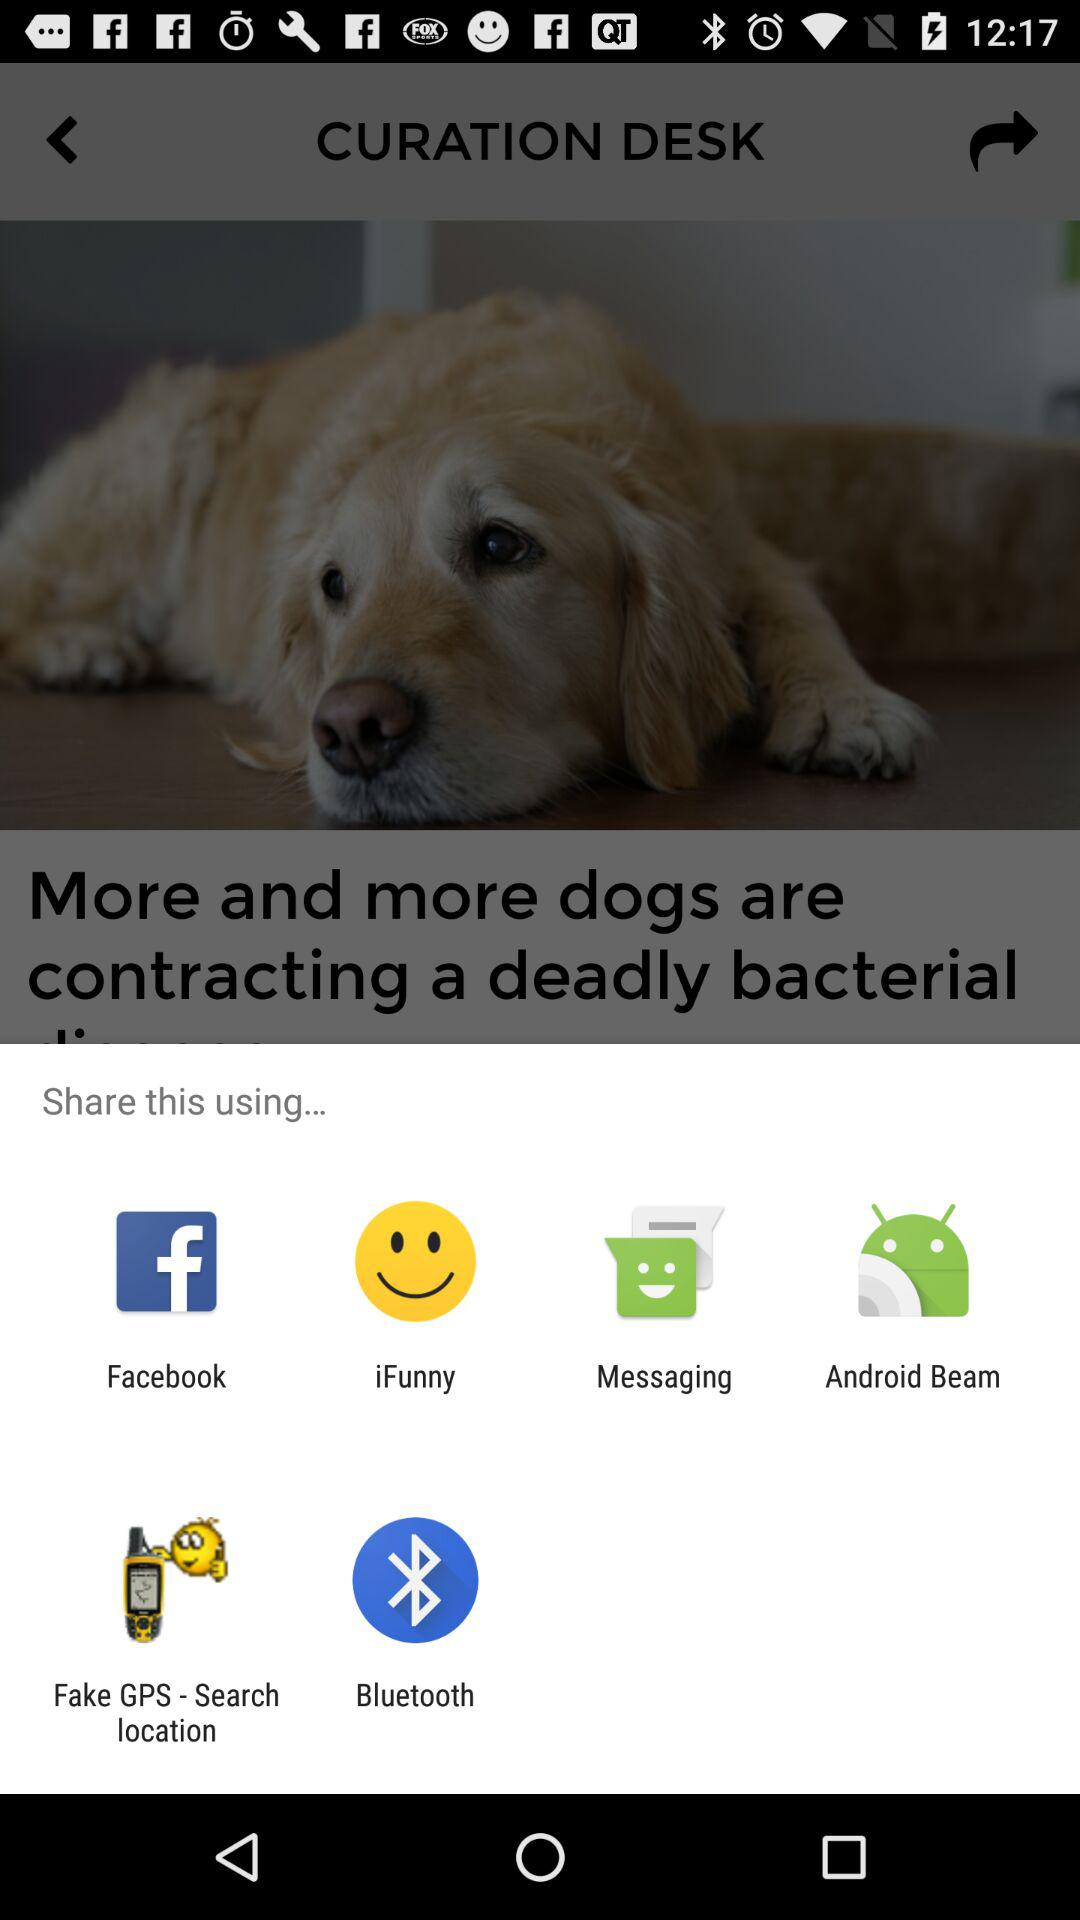Which are the different options available for sharing? The different options available for sharing are "Facebook", "iFunny", "Messaging", "Android Beam", "Fake GPS - Search location" and "Bluetooth". 